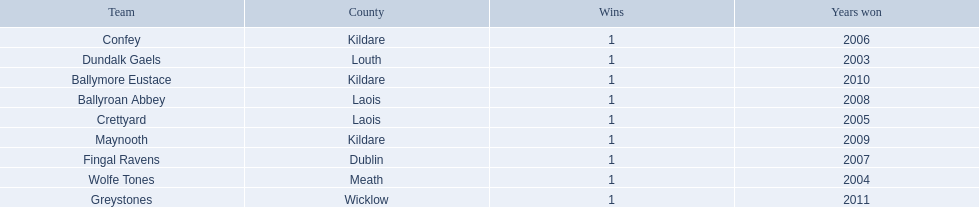What county is the team that won in 2009 from? Kildare. Would you mind parsing the complete table? {'header': ['Team', 'County', 'Wins', 'Years won'], 'rows': [['Confey', 'Kildare', '1', '2006'], ['Dundalk Gaels', 'Louth', '1', '2003'], ['Ballymore Eustace', 'Kildare', '1', '2010'], ['Ballyroan Abbey', 'Laois', '1', '2008'], ['Crettyard', 'Laois', '1', '2005'], ['Maynooth', 'Kildare', '1', '2009'], ['Fingal Ravens', 'Dublin', '1', '2007'], ['Wolfe Tones', 'Meath', '1', '2004'], ['Greystones', 'Wicklow', '1', '2011']]} What is the teams name? Maynooth. 